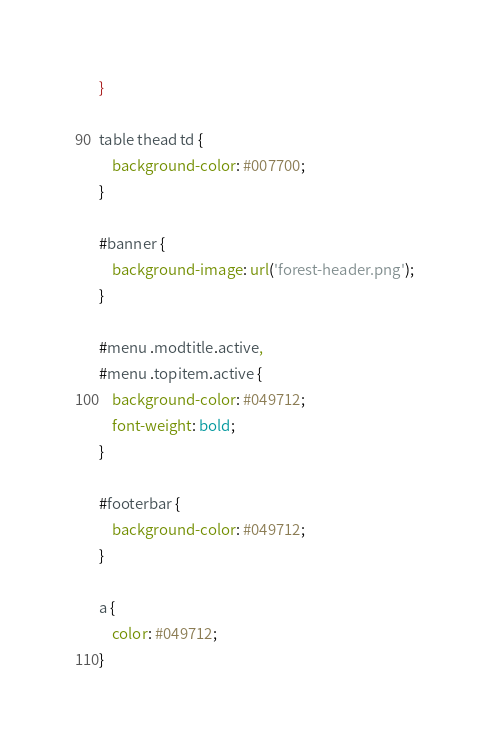<code> <loc_0><loc_0><loc_500><loc_500><_CSS_>}

table thead td {
	background-color: #007700;
}

#banner {
	background-image: url('forest-header.png');
}

#menu .modtitle.active,
#menu .topitem.active {
	background-color: #049712;
	font-weight: bold;
}

#footerbar {
	background-color: #049712;
}

a {
	color: #049712;
}
</code> 